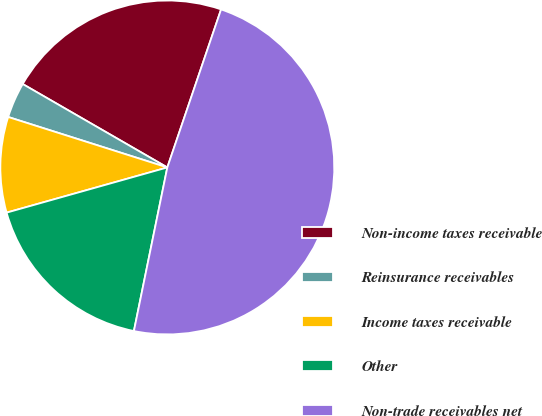Convert chart. <chart><loc_0><loc_0><loc_500><loc_500><pie_chart><fcel>Non-income taxes receivable<fcel>Reinsurance receivables<fcel>Income taxes receivable<fcel>Other<fcel>Non-trade receivables net<nl><fcel>21.89%<fcel>3.44%<fcel>9.25%<fcel>17.43%<fcel>47.99%<nl></chart> 